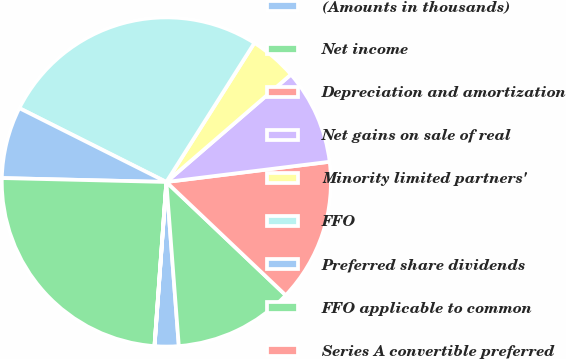Convert chart. <chart><loc_0><loc_0><loc_500><loc_500><pie_chart><fcel>(Amounts in thousands)<fcel>Net income<fcel>Depreciation and amortization<fcel>Net gains on sale of real<fcel>Minority limited partners'<fcel>FFO<fcel>Preferred share dividends<fcel>FFO applicable to common<fcel>Series A convertible preferred<nl><fcel>2.35%<fcel>11.71%<fcel>14.05%<fcel>9.37%<fcel>4.69%<fcel>26.58%<fcel>7.03%<fcel>24.23%<fcel>0.01%<nl></chart> 